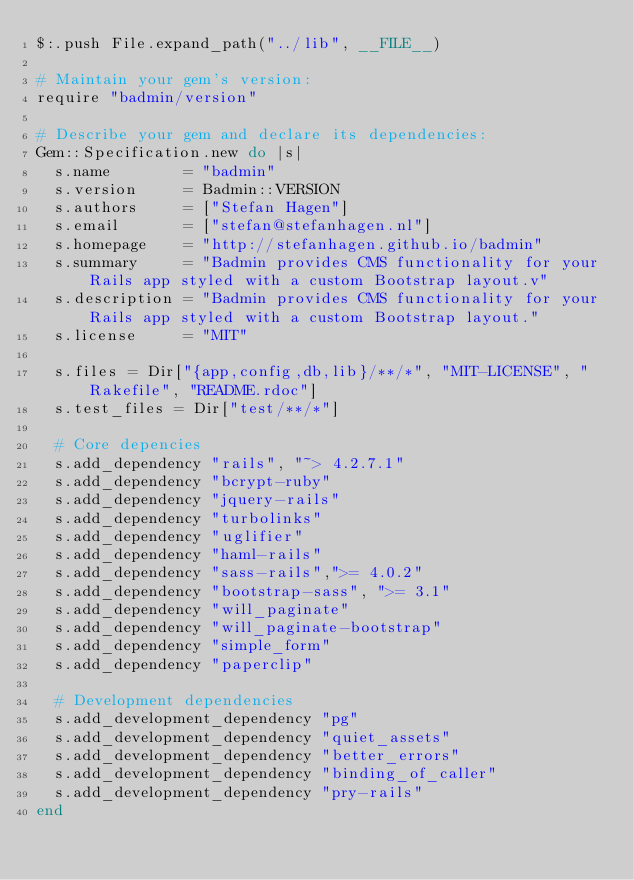Convert code to text. <code><loc_0><loc_0><loc_500><loc_500><_Ruby_>$:.push File.expand_path("../lib", __FILE__)

# Maintain your gem's version:
require "badmin/version"

# Describe your gem and declare its dependencies:
Gem::Specification.new do |s|
  s.name        = "badmin"
  s.version     = Badmin::VERSION
  s.authors     = ["Stefan Hagen"]
  s.email       = ["stefan@stefanhagen.nl"]
  s.homepage    = "http://stefanhagen.github.io/badmin"
  s.summary     = "Badmin provides CMS functionality for your Rails app styled with a custom Bootstrap layout.v"
  s.description = "Badmin provides CMS functionality for your Rails app styled with a custom Bootstrap layout."
  s.license     = "MIT"

  s.files = Dir["{app,config,db,lib}/**/*", "MIT-LICENSE", "Rakefile", "README.rdoc"]
  s.test_files = Dir["test/**/*"]

  # Core depencies
  s.add_dependency "rails", "~> 4.2.7.1"
  s.add_dependency "bcrypt-ruby"
  s.add_dependency "jquery-rails"
  s.add_dependency "turbolinks"
  s.add_dependency "uglifier"
  s.add_dependency "haml-rails"
  s.add_dependency "sass-rails",">= 4.0.2"
  s.add_dependency "bootstrap-sass", ">= 3.1"
  s.add_dependency "will_paginate"
  s.add_dependency "will_paginate-bootstrap"
  s.add_dependency "simple_form"
  s.add_dependency "paperclip"

  # Development dependencies
  s.add_development_dependency "pg"
  s.add_development_dependency "quiet_assets"
  s.add_development_dependency "better_errors"
  s.add_development_dependency "binding_of_caller"
  s.add_development_dependency "pry-rails"
end
</code> 